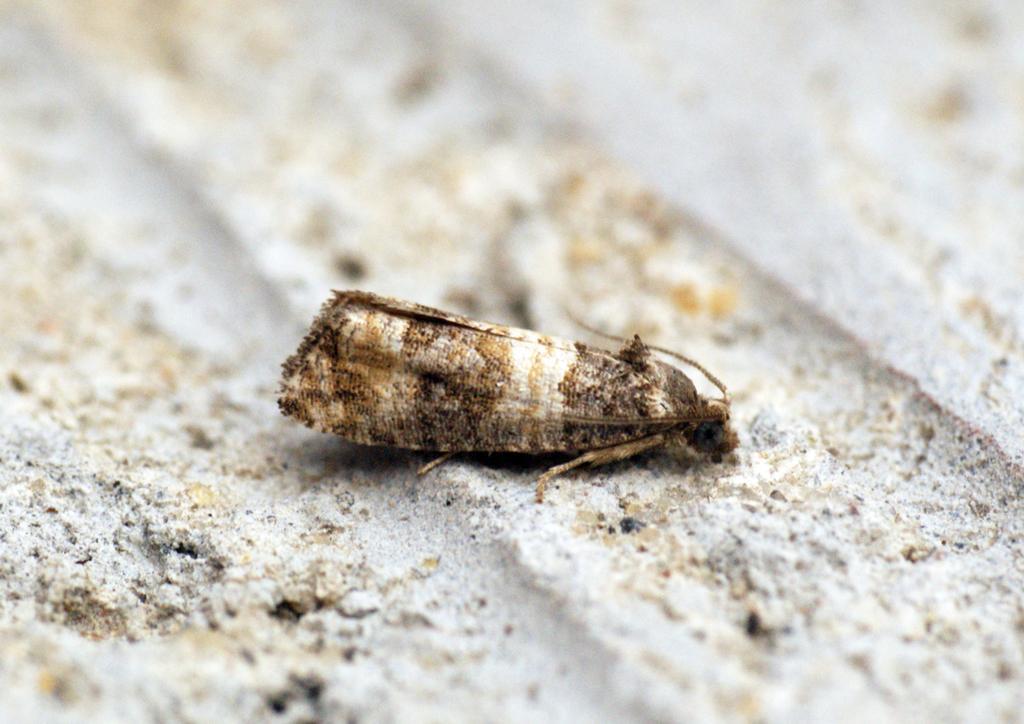Describe this image in one or two sentences. In this image there is an insect on the ground. 